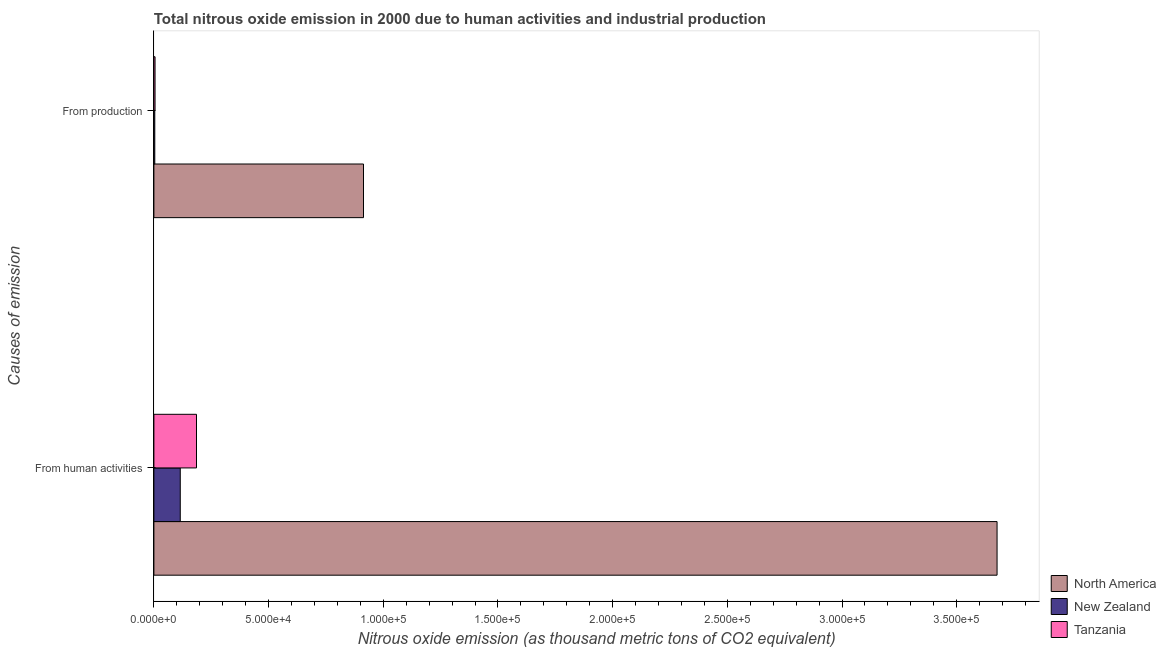Are the number of bars on each tick of the Y-axis equal?
Your answer should be compact. Yes. How many bars are there on the 1st tick from the top?
Your response must be concise. 3. How many bars are there on the 2nd tick from the bottom?
Provide a short and direct response. 3. What is the label of the 1st group of bars from the top?
Ensure brevity in your answer.  From production. What is the amount of emissions generated from industries in Tanzania?
Offer a very short reply. 507.1. Across all countries, what is the maximum amount of emissions generated from industries?
Your response must be concise. 9.14e+04. Across all countries, what is the minimum amount of emissions from human activities?
Keep it short and to the point. 1.15e+04. In which country was the amount of emissions generated from industries maximum?
Provide a short and direct response. North America. In which country was the amount of emissions generated from industries minimum?
Keep it short and to the point. New Zealand. What is the total amount of emissions from human activities in the graph?
Ensure brevity in your answer.  3.98e+05. What is the difference between the amount of emissions generated from industries in Tanzania and that in North America?
Provide a succinct answer. -9.09e+04. What is the difference between the amount of emissions generated from industries in North America and the amount of emissions from human activities in New Zealand?
Your response must be concise. 7.99e+04. What is the average amount of emissions from human activities per country?
Keep it short and to the point. 1.33e+05. What is the difference between the amount of emissions from human activities and amount of emissions generated from industries in New Zealand?
Give a very brief answer. 1.11e+04. In how many countries, is the amount of emissions generated from industries greater than 170000 thousand metric tons?
Make the answer very short. 0. What is the ratio of the amount of emissions from human activities in New Zealand to that in North America?
Ensure brevity in your answer.  0.03. Is the amount of emissions from human activities in Tanzania less than that in North America?
Make the answer very short. Yes. What does the 3rd bar from the top in From human activities represents?
Your response must be concise. North America. What does the 3rd bar from the bottom in From production represents?
Ensure brevity in your answer.  Tanzania. Are all the bars in the graph horizontal?
Give a very brief answer. Yes. How many countries are there in the graph?
Your answer should be compact. 3. Does the graph contain any zero values?
Provide a short and direct response. No. How are the legend labels stacked?
Provide a succinct answer. Vertical. What is the title of the graph?
Provide a succinct answer. Total nitrous oxide emission in 2000 due to human activities and industrial production. Does "Thailand" appear as one of the legend labels in the graph?
Offer a terse response. No. What is the label or title of the X-axis?
Provide a short and direct response. Nitrous oxide emission (as thousand metric tons of CO2 equivalent). What is the label or title of the Y-axis?
Ensure brevity in your answer.  Causes of emission. What is the Nitrous oxide emission (as thousand metric tons of CO2 equivalent) of North America in From human activities?
Give a very brief answer. 3.68e+05. What is the Nitrous oxide emission (as thousand metric tons of CO2 equivalent) in New Zealand in From human activities?
Your answer should be very brief. 1.15e+04. What is the Nitrous oxide emission (as thousand metric tons of CO2 equivalent) of Tanzania in From human activities?
Keep it short and to the point. 1.86e+04. What is the Nitrous oxide emission (as thousand metric tons of CO2 equivalent) in North America in From production?
Your response must be concise. 9.14e+04. What is the Nitrous oxide emission (as thousand metric tons of CO2 equivalent) in New Zealand in From production?
Your answer should be compact. 390.5. What is the Nitrous oxide emission (as thousand metric tons of CO2 equivalent) in Tanzania in From production?
Ensure brevity in your answer.  507.1. Across all Causes of emission, what is the maximum Nitrous oxide emission (as thousand metric tons of CO2 equivalent) of North America?
Keep it short and to the point. 3.68e+05. Across all Causes of emission, what is the maximum Nitrous oxide emission (as thousand metric tons of CO2 equivalent) of New Zealand?
Provide a succinct answer. 1.15e+04. Across all Causes of emission, what is the maximum Nitrous oxide emission (as thousand metric tons of CO2 equivalent) of Tanzania?
Give a very brief answer. 1.86e+04. Across all Causes of emission, what is the minimum Nitrous oxide emission (as thousand metric tons of CO2 equivalent) of North America?
Your response must be concise. 9.14e+04. Across all Causes of emission, what is the minimum Nitrous oxide emission (as thousand metric tons of CO2 equivalent) in New Zealand?
Your answer should be compact. 390.5. Across all Causes of emission, what is the minimum Nitrous oxide emission (as thousand metric tons of CO2 equivalent) in Tanzania?
Offer a very short reply. 507.1. What is the total Nitrous oxide emission (as thousand metric tons of CO2 equivalent) in North America in the graph?
Provide a short and direct response. 4.59e+05. What is the total Nitrous oxide emission (as thousand metric tons of CO2 equivalent) in New Zealand in the graph?
Ensure brevity in your answer.  1.19e+04. What is the total Nitrous oxide emission (as thousand metric tons of CO2 equivalent) of Tanzania in the graph?
Make the answer very short. 1.91e+04. What is the difference between the Nitrous oxide emission (as thousand metric tons of CO2 equivalent) of North America in From human activities and that in From production?
Make the answer very short. 2.76e+05. What is the difference between the Nitrous oxide emission (as thousand metric tons of CO2 equivalent) of New Zealand in From human activities and that in From production?
Give a very brief answer. 1.11e+04. What is the difference between the Nitrous oxide emission (as thousand metric tons of CO2 equivalent) in Tanzania in From human activities and that in From production?
Ensure brevity in your answer.  1.81e+04. What is the difference between the Nitrous oxide emission (as thousand metric tons of CO2 equivalent) of North America in From human activities and the Nitrous oxide emission (as thousand metric tons of CO2 equivalent) of New Zealand in From production?
Give a very brief answer. 3.67e+05. What is the difference between the Nitrous oxide emission (as thousand metric tons of CO2 equivalent) of North America in From human activities and the Nitrous oxide emission (as thousand metric tons of CO2 equivalent) of Tanzania in From production?
Your answer should be very brief. 3.67e+05. What is the difference between the Nitrous oxide emission (as thousand metric tons of CO2 equivalent) of New Zealand in From human activities and the Nitrous oxide emission (as thousand metric tons of CO2 equivalent) of Tanzania in From production?
Provide a short and direct response. 1.10e+04. What is the average Nitrous oxide emission (as thousand metric tons of CO2 equivalent) of North America per Causes of emission?
Give a very brief answer. 2.29e+05. What is the average Nitrous oxide emission (as thousand metric tons of CO2 equivalent) in New Zealand per Causes of emission?
Ensure brevity in your answer.  5944.55. What is the average Nitrous oxide emission (as thousand metric tons of CO2 equivalent) of Tanzania per Causes of emission?
Provide a short and direct response. 9543.65. What is the difference between the Nitrous oxide emission (as thousand metric tons of CO2 equivalent) of North America and Nitrous oxide emission (as thousand metric tons of CO2 equivalent) of New Zealand in From human activities?
Ensure brevity in your answer.  3.56e+05. What is the difference between the Nitrous oxide emission (as thousand metric tons of CO2 equivalent) of North America and Nitrous oxide emission (as thousand metric tons of CO2 equivalent) of Tanzania in From human activities?
Offer a very short reply. 3.49e+05. What is the difference between the Nitrous oxide emission (as thousand metric tons of CO2 equivalent) in New Zealand and Nitrous oxide emission (as thousand metric tons of CO2 equivalent) in Tanzania in From human activities?
Ensure brevity in your answer.  -7081.6. What is the difference between the Nitrous oxide emission (as thousand metric tons of CO2 equivalent) of North America and Nitrous oxide emission (as thousand metric tons of CO2 equivalent) of New Zealand in From production?
Offer a very short reply. 9.10e+04. What is the difference between the Nitrous oxide emission (as thousand metric tons of CO2 equivalent) in North America and Nitrous oxide emission (as thousand metric tons of CO2 equivalent) in Tanzania in From production?
Your answer should be compact. 9.09e+04. What is the difference between the Nitrous oxide emission (as thousand metric tons of CO2 equivalent) in New Zealand and Nitrous oxide emission (as thousand metric tons of CO2 equivalent) in Tanzania in From production?
Offer a very short reply. -116.6. What is the ratio of the Nitrous oxide emission (as thousand metric tons of CO2 equivalent) in North America in From human activities to that in From production?
Provide a succinct answer. 4.02. What is the ratio of the Nitrous oxide emission (as thousand metric tons of CO2 equivalent) in New Zealand in From human activities to that in From production?
Make the answer very short. 29.45. What is the ratio of the Nitrous oxide emission (as thousand metric tons of CO2 equivalent) of Tanzania in From human activities to that in From production?
Keep it short and to the point. 36.64. What is the difference between the highest and the second highest Nitrous oxide emission (as thousand metric tons of CO2 equivalent) of North America?
Provide a short and direct response. 2.76e+05. What is the difference between the highest and the second highest Nitrous oxide emission (as thousand metric tons of CO2 equivalent) of New Zealand?
Make the answer very short. 1.11e+04. What is the difference between the highest and the second highest Nitrous oxide emission (as thousand metric tons of CO2 equivalent) in Tanzania?
Your response must be concise. 1.81e+04. What is the difference between the highest and the lowest Nitrous oxide emission (as thousand metric tons of CO2 equivalent) of North America?
Your answer should be very brief. 2.76e+05. What is the difference between the highest and the lowest Nitrous oxide emission (as thousand metric tons of CO2 equivalent) in New Zealand?
Give a very brief answer. 1.11e+04. What is the difference between the highest and the lowest Nitrous oxide emission (as thousand metric tons of CO2 equivalent) in Tanzania?
Keep it short and to the point. 1.81e+04. 